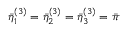<formula> <loc_0><loc_0><loc_500><loc_500>\bar { \eta } _ { 1 } ^ { ( 3 ) } = \bar { \eta } _ { 2 } ^ { ( 3 ) } = \bar { \eta } _ { 3 } ^ { ( 3 ) } = \bar { \pi }</formula> 